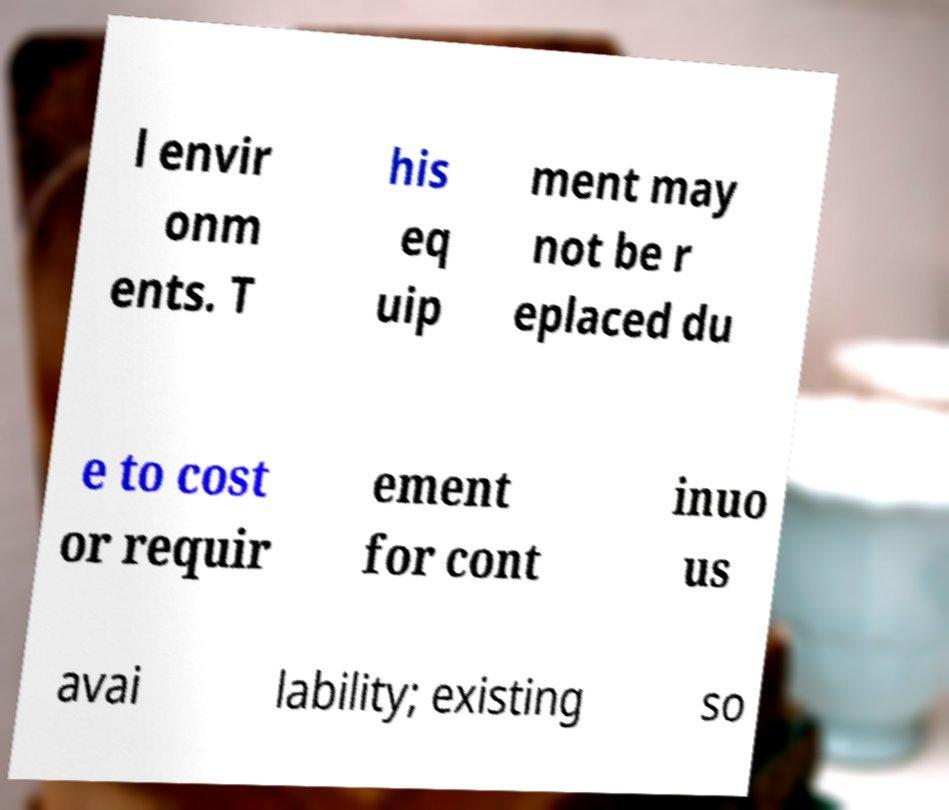Please read and relay the text visible in this image. What does it say? l envir onm ents. T his eq uip ment may not be r eplaced du e to cost or requir ement for cont inuo us avai lability; existing so 